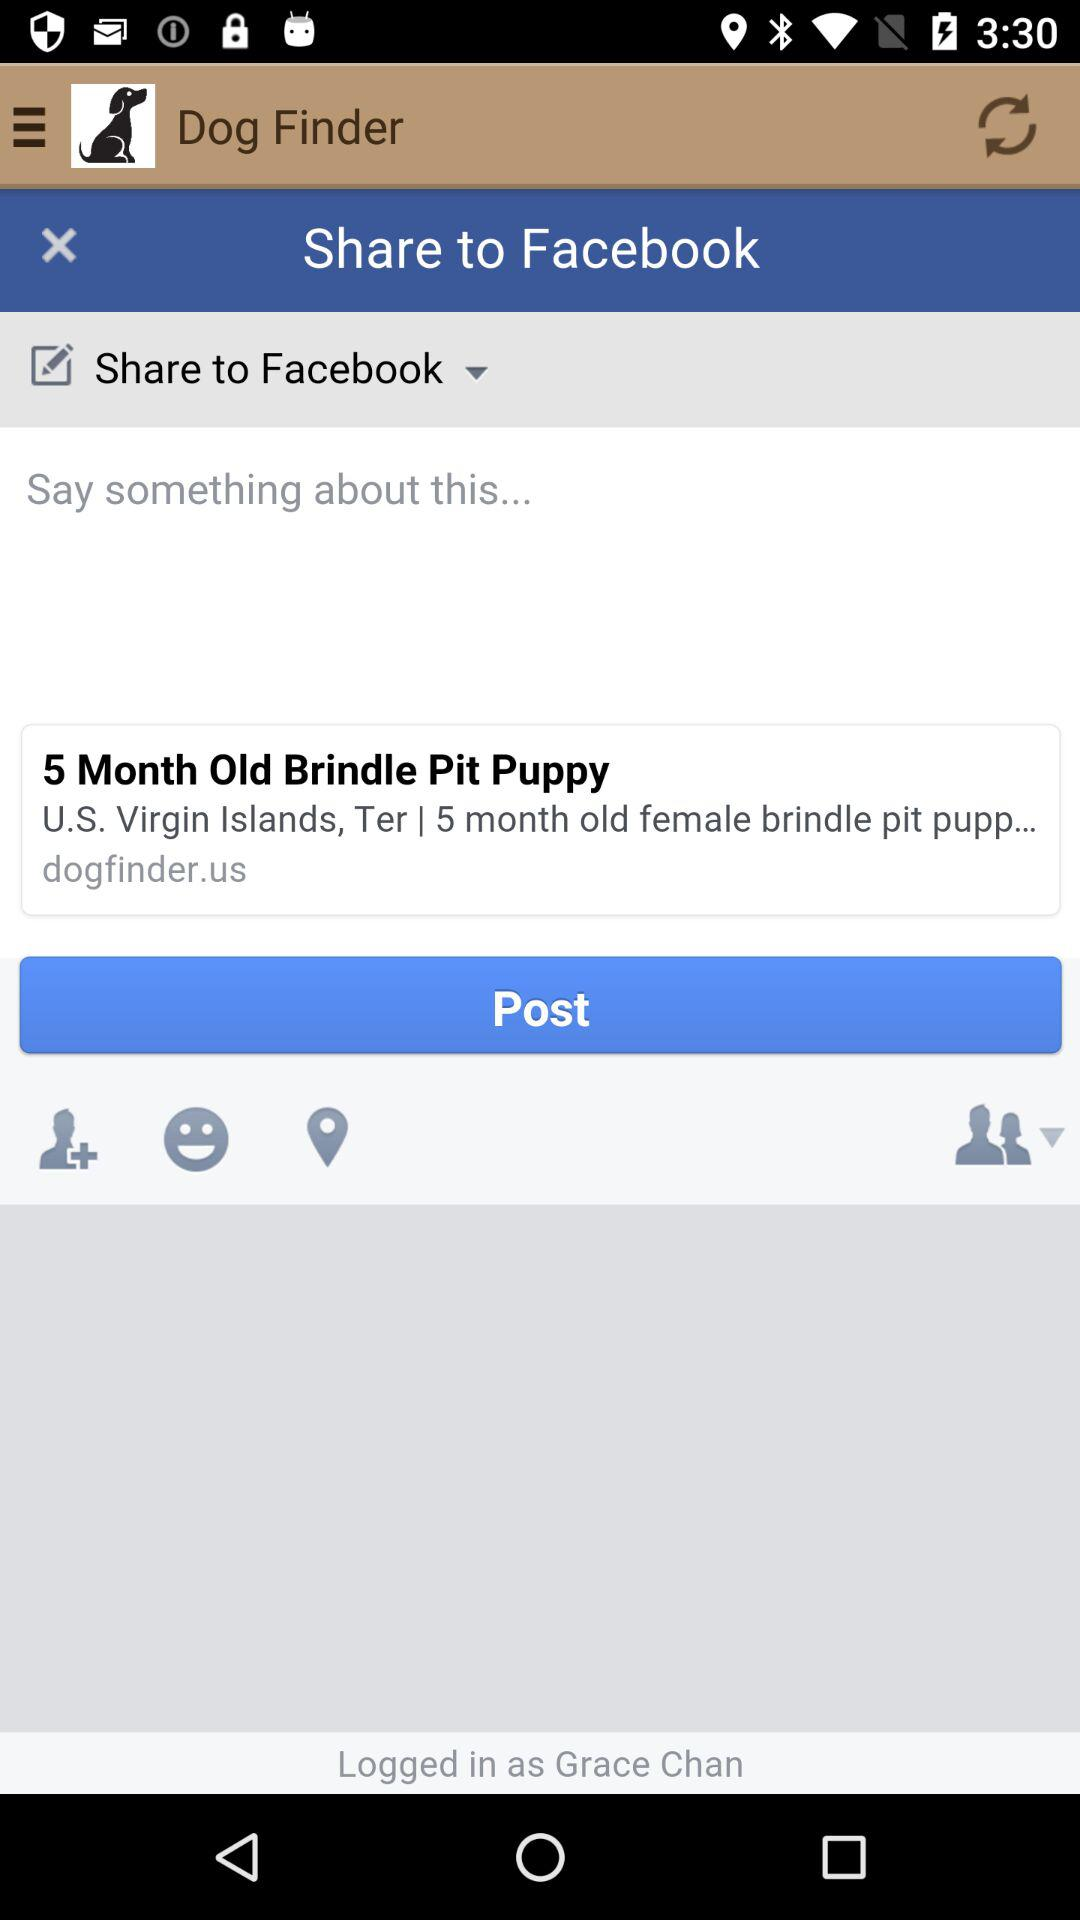How old is the brindle pit puppy? The brindle pit puppy is 5 month old. 